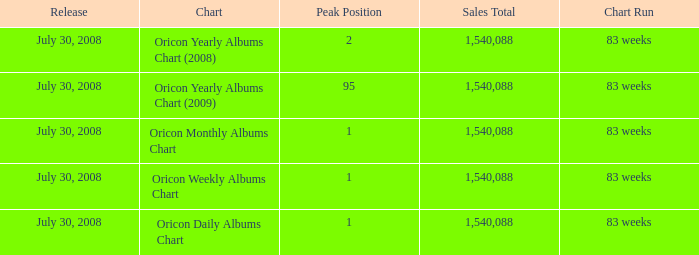Which Chart has a Peak Position of 1? Oricon Daily Albums Chart, Oricon Weekly Albums Chart, Oricon Monthly Albums Chart. 